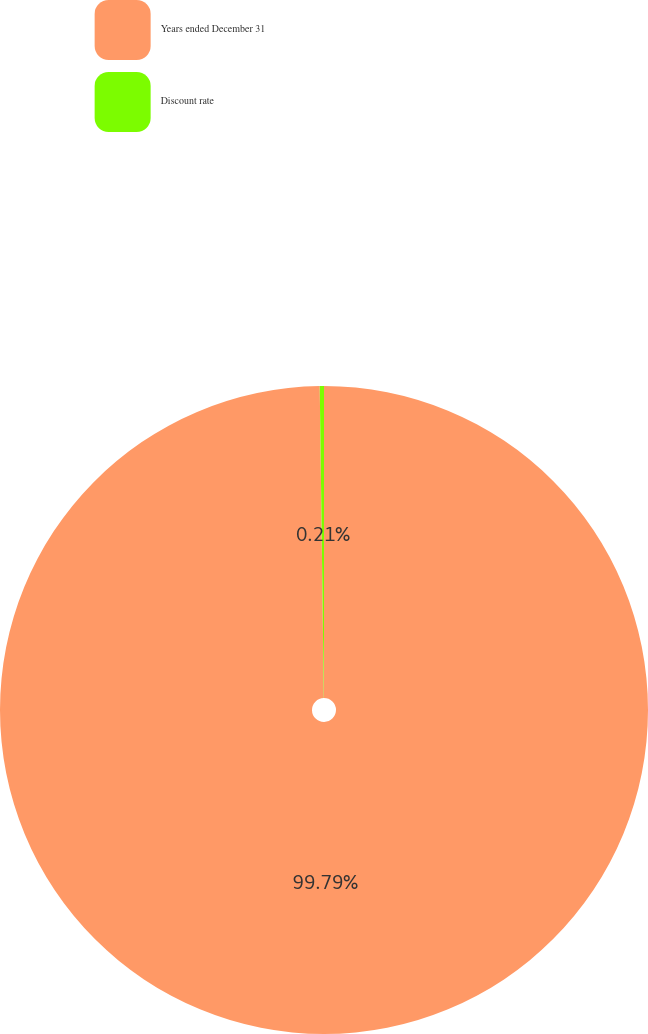Convert chart. <chart><loc_0><loc_0><loc_500><loc_500><pie_chart><fcel>Years ended December 31<fcel>Discount rate<nl><fcel>99.79%<fcel>0.21%<nl></chart> 